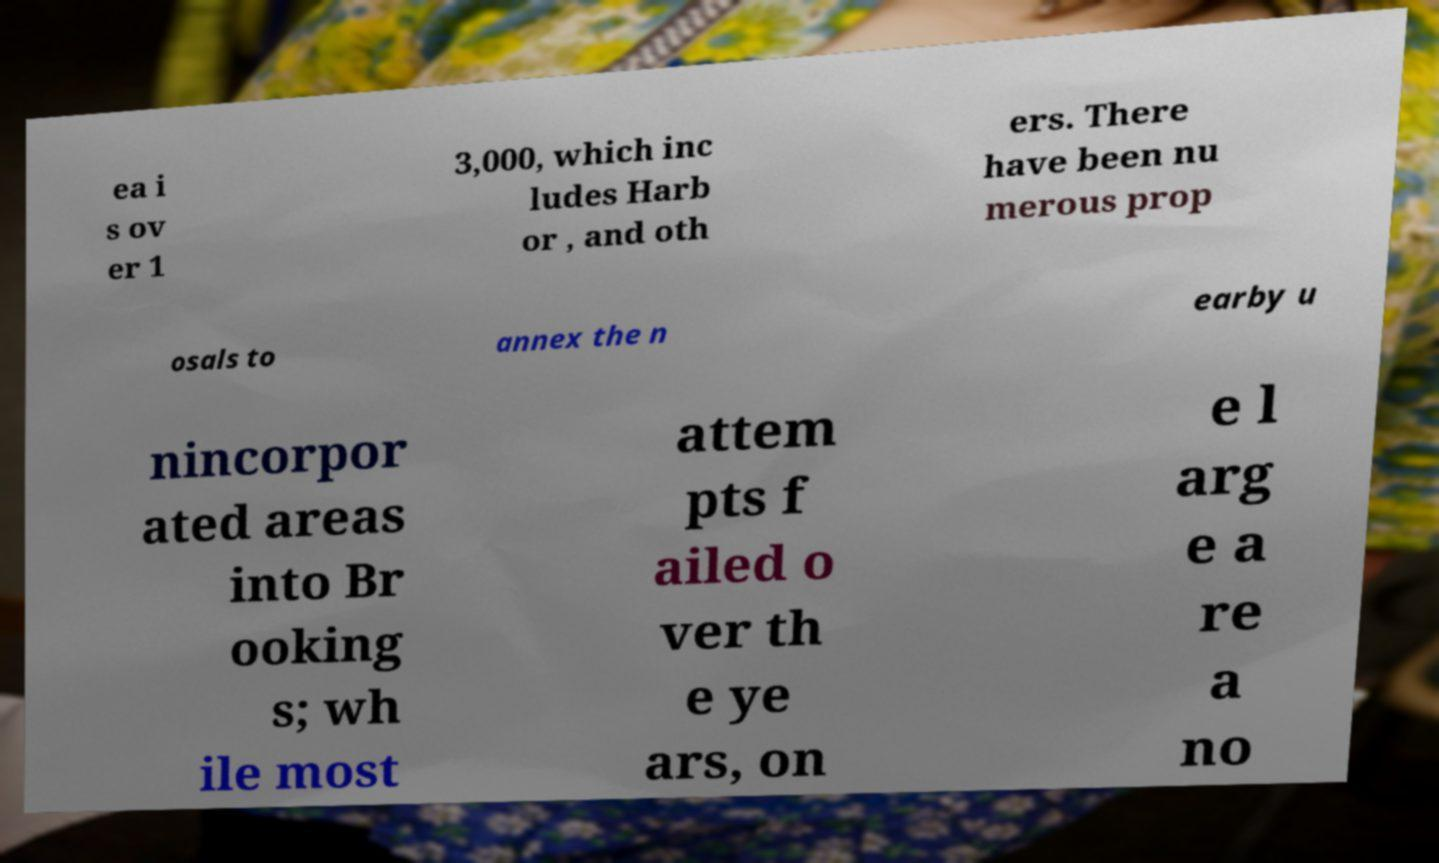Can you accurately transcribe the text from the provided image for me? ea i s ov er 1 3,000, which inc ludes Harb or , and oth ers. There have been nu merous prop osals to annex the n earby u nincorpor ated areas into Br ooking s; wh ile most attem pts f ailed o ver th e ye ars, on e l arg e a re a no 